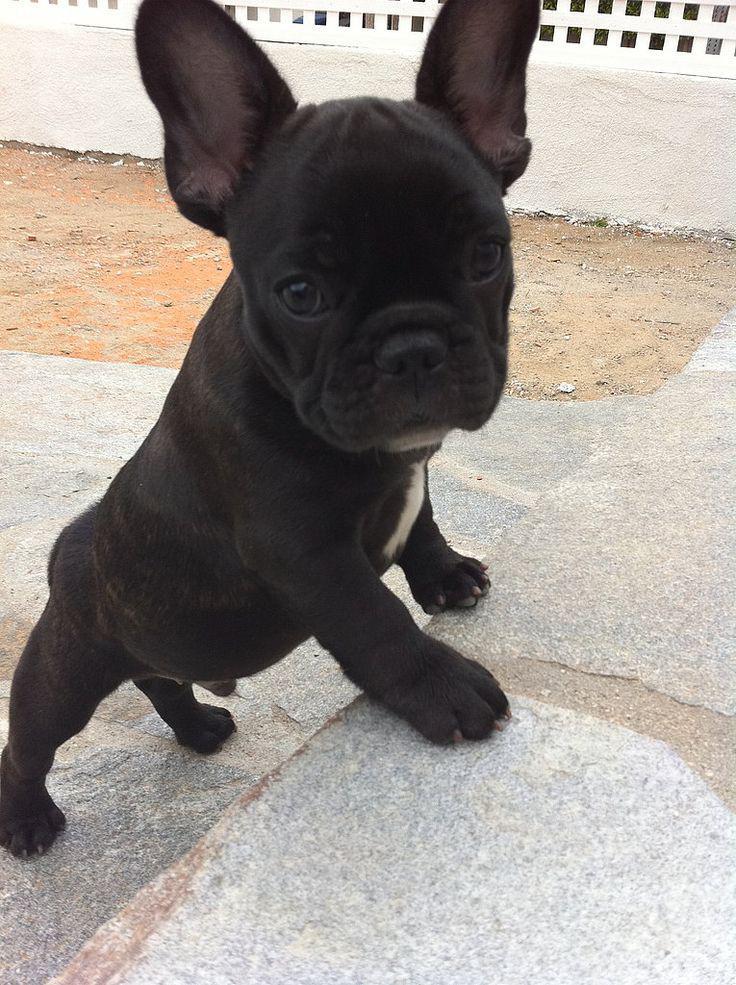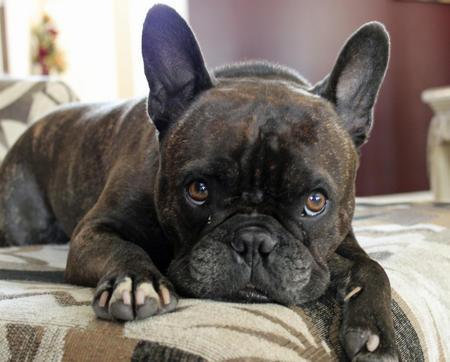The first image is the image on the left, the second image is the image on the right. Evaluate the accuracy of this statement regarding the images: "There are three dogs.". Is it true? Answer yes or no. No. The first image is the image on the left, the second image is the image on the right. Evaluate the accuracy of this statement regarding the images: "One image includes exactly twice as many big-eared dogs in the foreground as the other image.". Is it true? Answer yes or no. No. 